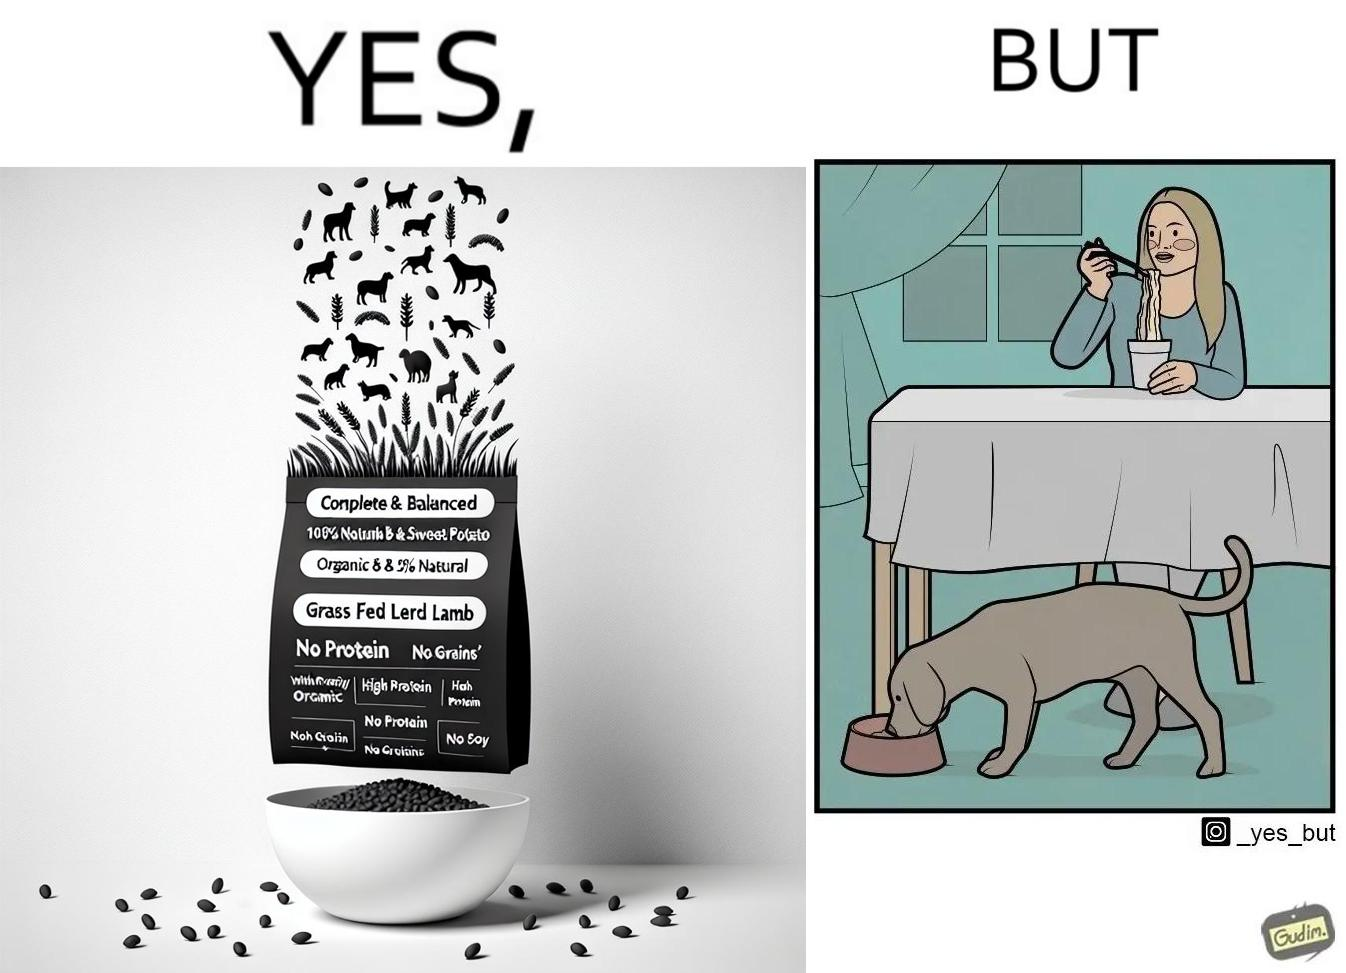What is shown in this image? The image is funny because while the food for the dog that the woman pours is well balanced, the food that she herself is eating is bad for her health. 